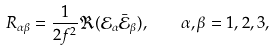<formula> <loc_0><loc_0><loc_500><loc_500>R _ { \alpha \beta } = \frac { 1 } { 2 f ^ { 2 } } \Re ( \mathcal { E } _ { \alpha } \bar { \mathcal { E } } _ { \beta } ) , \quad \alpha , \beta = 1 , 2 , 3 ,</formula> 